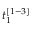Convert formula to latex. <formula><loc_0><loc_0><loc_500><loc_500>t _ { 1 } ^ { [ 1 - 3 ] }</formula> 